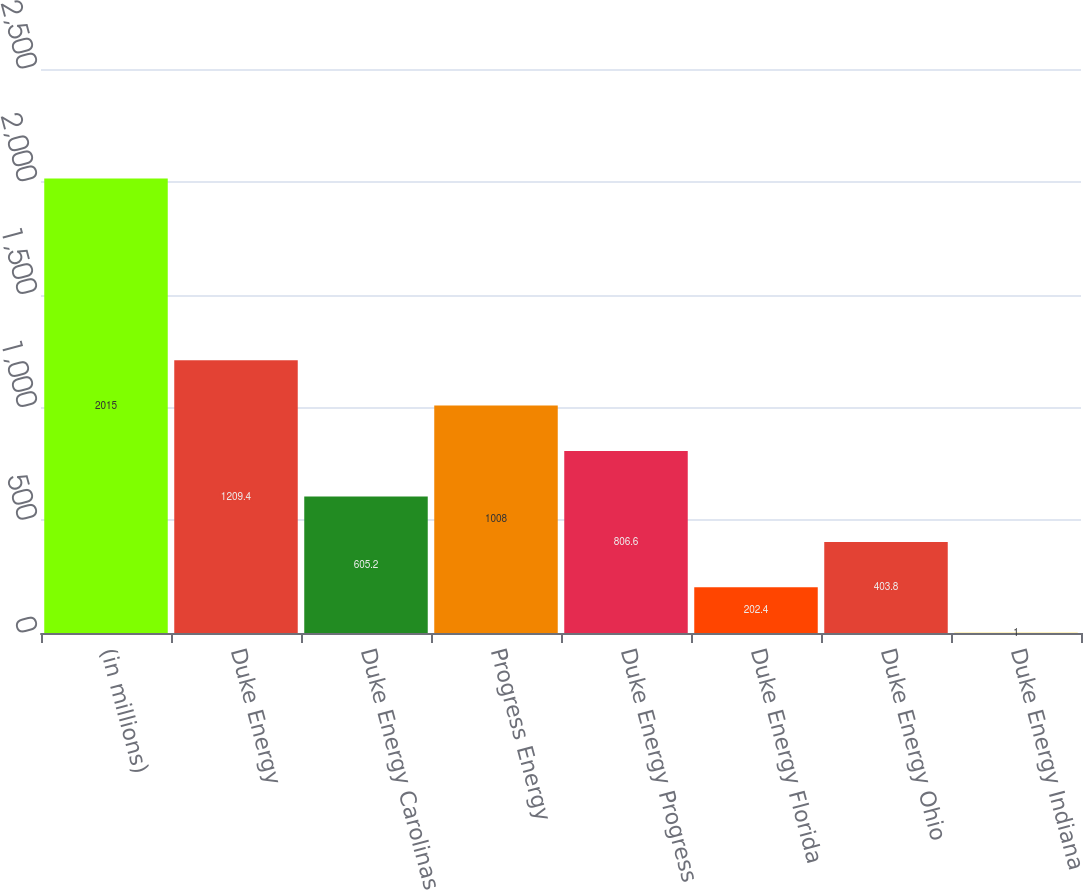Convert chart. <chart><loc_0><loc_0><loc_500><loc_500><bar_chart><fcel>(in millions)<fcel>Duke Energy<fcel>Duke Energy Carolinas<fcel>Progress Energy<fcel>Duke Energy Progress<fcel>Duke Energy Florida<fcel>Duke Energy Ohio<fcel>Duke Energy Indiana<nl><fcel>2015<fcel>1209.4<fcel>605.2<fcel>1008<fcel>806.6<fcel>202.4<fcel>403.8<fcel>1<nl></chart> 